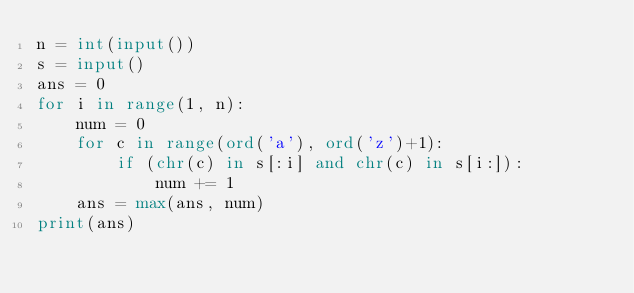Convert code to text. <code><loc_0><loc_0><loc_500><loc_500><_Python_>n = int(input())
s = input()
ans = 0
for i in range(1, n):
    num = 0
    for c in range(ord('a'), ord('z')+1):
        if (chr(c) in s[:i] and chr(c) in s[i:]):
            num += 1
    ans = max(ans, num)
print(ans)</code> 